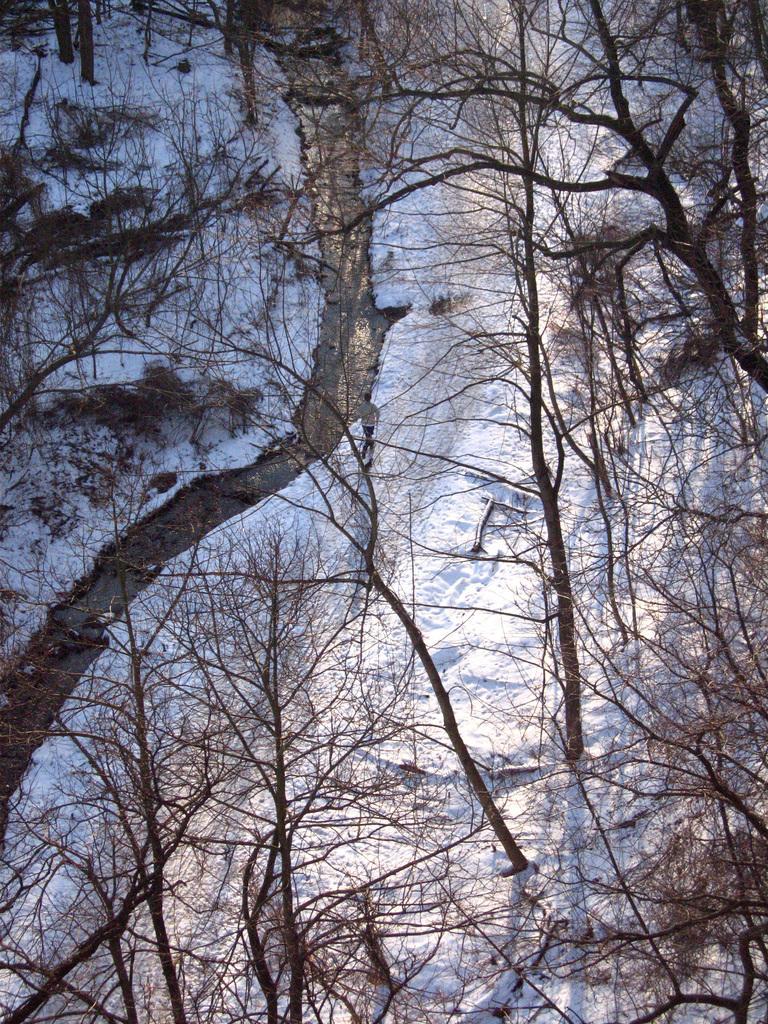How would you summarize this image in a sentence or two? In this picture we can see some trees, at the bottom there is snow. 